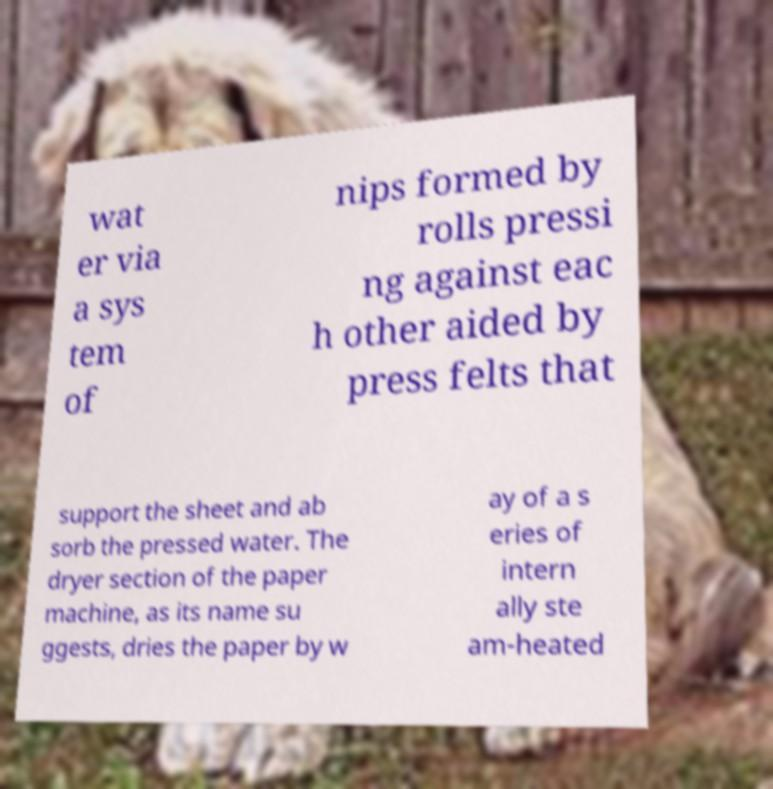Can you read and provide the text displayed in the image?This photo seems to have some interesting text. Can you extract and type it out for me? wat er via a sys tem of nips formed by rolls pressi ng against eac h other aided by press felts that support the sheet and ab sorb the pressed water. The dryer section of the paper machine, as its name su ggests, dries the paper by w ay of a s eries of intern ally ste am-heated 